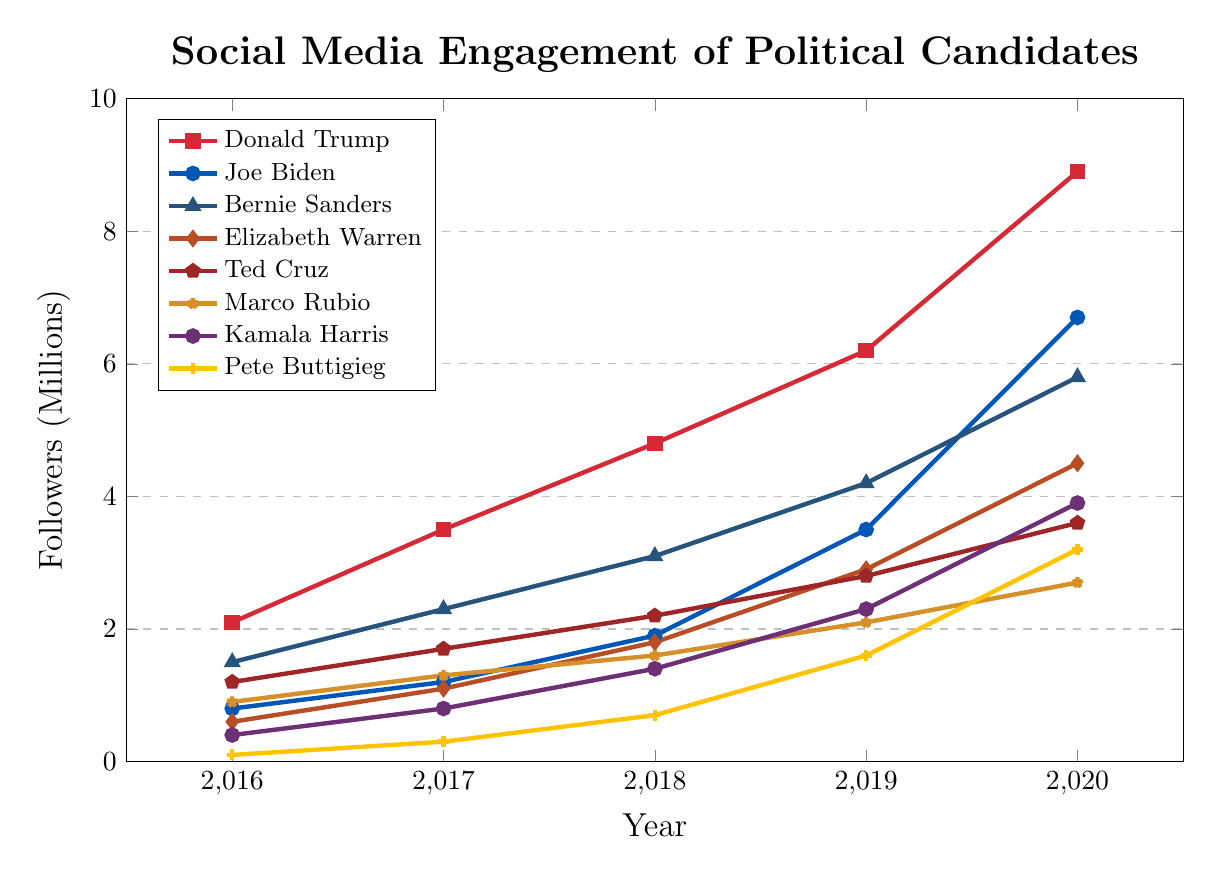Which candidate had the highest social media engagement in 2020? Observing the graph, the top line is the one representing Trump, clearly reaching the highest follower mark at just under 9 million.
Answer: Donald Trump Which candidate showed the most significant increase in social media engagement between 2019 and 2020? From the data points, comparing the differences between 2019 and 2020, we see that Trump went from 6.2M to 8.9M, an increase of 2.7M, which is the highest among all candidates.
Answer: Donald Trump Which candidate had the lowest social media engagement in 2016? Looking at the 2016 data points, Pete Buttigieg had the lowest engagement with 0.1M followers.
Answer: Pete Buttigieg What is the average social media engagement for Kamala Harris over the five years? Summing Kamala Harris's values from 2016 through 2020 ((0.4 + 0.8 + 1.4 + 2.3 + 3.9) / 5), the average engagement is 1.76M.
Answer: 1.76M Which two candidates had nearly equal engagement in 2020? Comparing the data for 2020, Trump had 8.9M, Biden had 6.7M, Sanders had 5.8M, and Warren had 4.5M. Rubio and Harris had 2.7M and 3.9M respectively. No candidates had near-equal engagements except Harris and Buttigieg, who were somewhat closer (3.9M and 3.2M).
Answer: Kamala Harris and Pete Buttigieg Between which two years did Joe Biden see the sharpest rise in social media engagement? Checking Biden's engagement, the most significant increase was between 2019 (3.5M) and 2020 (6.7M), with an increase of 3.2M.
Answer: 2019 and 2020 Who had consistently lower engagement than Bernie Sanders but higher than Marco Rubio from 2016 to 2020? Ted Cruz consistently stays between Sanders and Rubio across all years in the plotted data.
Answer: Ted Cruz By what margin did Trump's social media engagement exceed Biden's in 2020? The graph shows Trump with 8.9M and Biden with 6.7M in 2020, resulting in a margin of 2.2M.
Answer: 2.2M How did Pete Buttigieg's engagement compare to Elizabeth Warren's from 2018 to 2020? For 2018, Warren had 1.8M and Buttigieg had 0.7M; in 2019, Warren had 2.9M and Buttigieg had 1.6M; in 2020, Warren had 4.5M and Buttigieg had 3.2M. In each of these years, Warren's engagement was consistently higher than Buttigieg's.
Answer: Warren had consistently higher engagement 